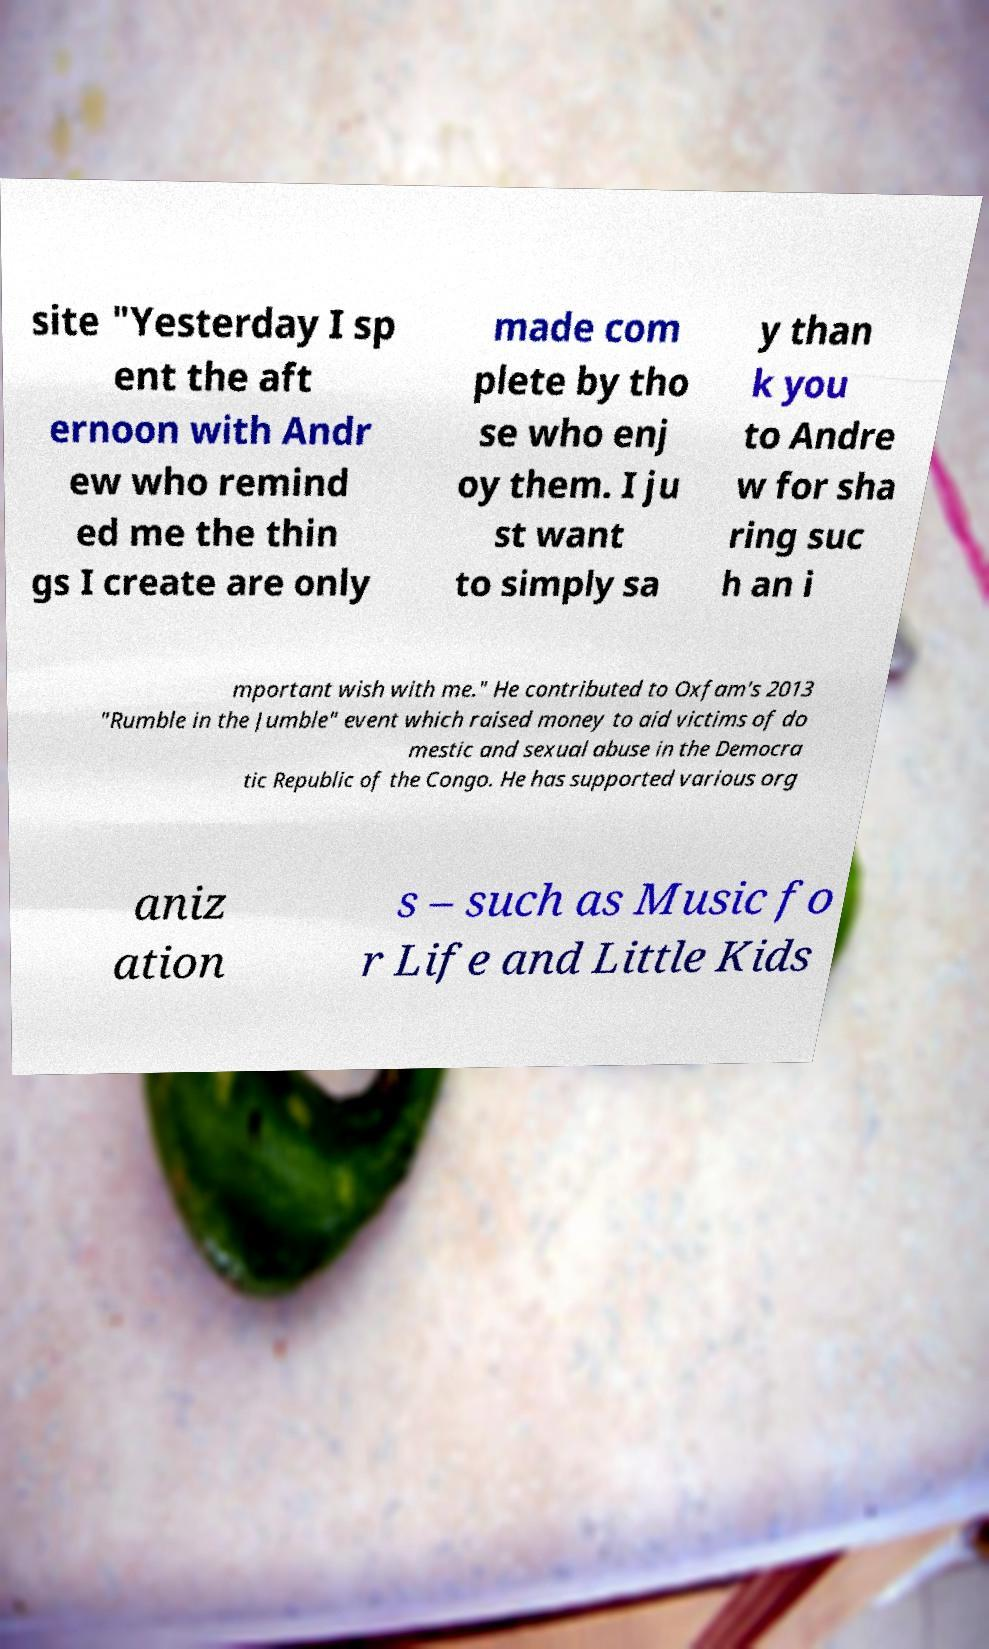Can you read and provide the text displayed in the image?This photo seems to have some interesting text. Can you extract and type it out for me? site "Yesterday I sp ent the aft ernoon with Andr ew who remind ed me the thin gs I create are only made com plete by tho se who enj oy them. I ju st want to simply sa y than k you to Andre w for sha ring suc h an i mportant wish with me." He contributed to Oxfam's 2013 "Rumble in the Jumble" event which raised money to aid victims of do mestic and sexual abuse in the Democra tic Republic of the Congo. He has supported various org aniz ation s – such as Music fo r Life and Little Kids 